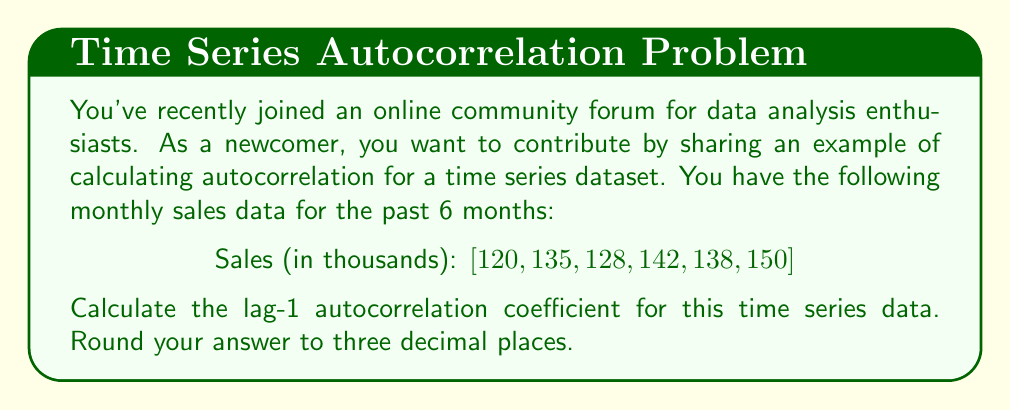Help me with this question. To calculate the lag-1 autocorrelation coefficient for this time series data, we'll follow these steps:

1. Calculate the mean of the series:
   $$\bar{x} = \frac{120 + 135 + 128 + 142 + 138 + 150}{6} = 135.5$$

2. Calculate the numerator of the autocorrelation formula:
   $$\sum_{t=2}^{n} (x_t - \bar{x})(x_{t-1} - \bar{x})$$
   
   $(135 - 135.5)(120 - 135.5) + (128 - 135.5)(135 - 135.5) + (142 - 135.5)(128 - 135.5) + (138 - 135.5)(142 - 135.5) + (150 - 135.5)(138 - 135.5)$
   
   $= (-0.5)(-15.5) + (-7.5)(-0.5) + (6.5)(-7.5) + (2.5)(6.5) + (14.5)(2.5)$
   
   $= 7.75 + 3.75 - 48.75 + 16.25 + 36.25 = 15.25$

3. Calculate the denominator of the autocorrelation formula:
   $$\sum_{t=1}^{n} (x_t - \bar{x})^2$$
   
   $(120 - 135.5)^2 + (135 - 135.5)^2 + (128 - 135.5)^2 + (142 - 135.5)^2 + (138 - 135.5)^2 + (150 - 135.5)^2$
   
   $= 240.25 + 0.25 + 56.25 + 42.25 + 6.25 + 210.25 = 555.5$

4. Calculate the lag-1 autocorrelation coefficient:
   $$r_1 = \frac{\sum_{t=2}^{n} (x_t - \bar{x})(x_{t-1} - \bar{x})}{\sum_{t=1}^{n} (x_t - \bar{x})^2}$$
   
   $$r_1 = \frac{15.25}{555.5} \approx 0.027$$

5. Round the result to three decimal places: 0.027
Answer: 0.027 